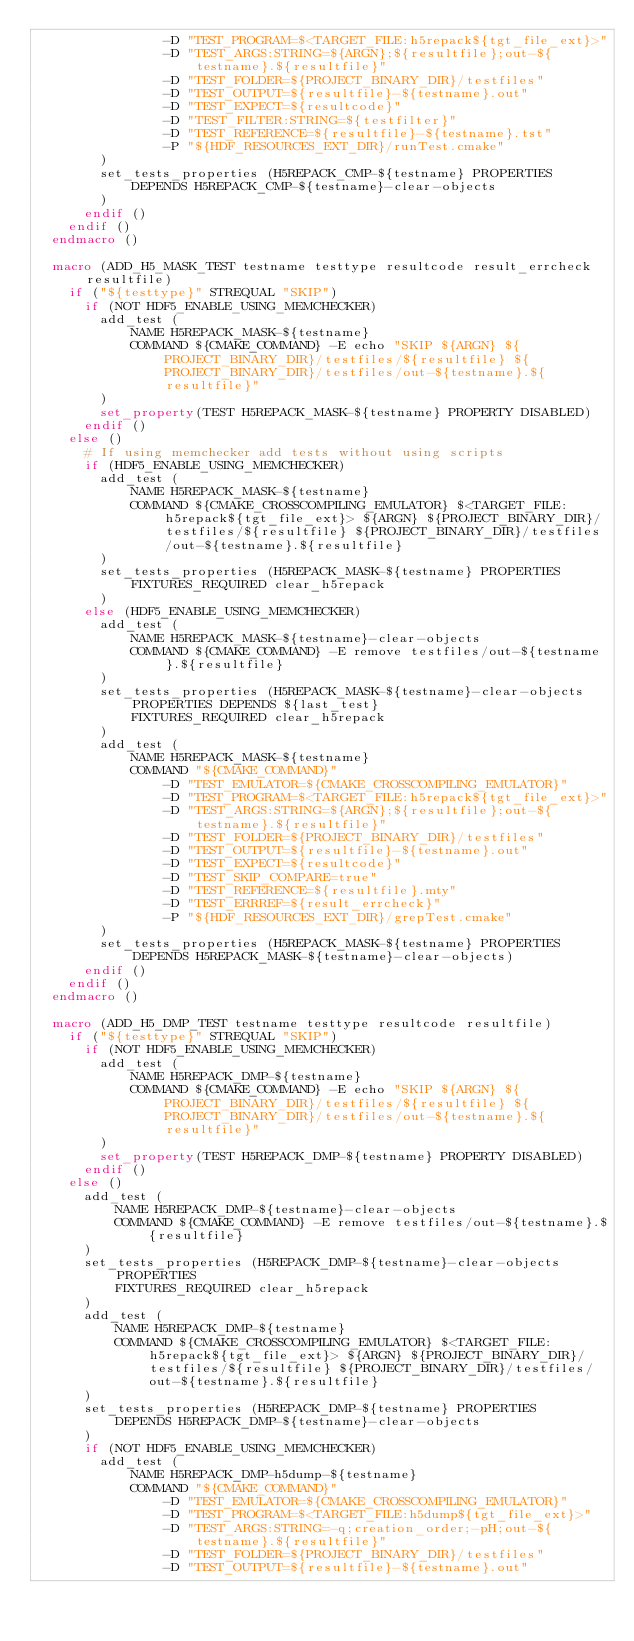<code> <loc_0><loc_0><loc_500><loc_500><_CMake_>                -D "TEST_PROGRAM=$<TARGET_FILE:h5repack${tgt_file_ext}>"
                -D "TEST_ARGS:STRING=${ARGN};${resultfile};out-${testname}.${resultfile}"
                -D "TEST_FOLDER=${PROJECT_BINARY_DIR}/testfiles"
                -D "TEST_OUTPUT=${resultfile}-${testname}.out"
                -D "TEST_EXPECT=${resultcode}"
                -D "TEST_FILTER:STRING=${testfilter}"
                -D "TEST_REFERENCE=${resultfile}-${testname}.tst"
                -P "${HDF_RESOURCES_EXT_DIR}/runTest.cmake"
        )
        set_tests_properties (H5REPACK_CMP-${testname} PROPERTIES
            DEPENDS H5REPACK_CMP-${testname}-clear-objects
        )
      endif ()
    endif ()
  endmacro ()

  macro (ADD_H5_MASK_TEST testname testtype resultcode result_errcheck resultfile)
    if ("${testtype}" STREQUAL "SKIP")
      if (NOT HDF5_ENABLE_USING_MEMCHECKER)
        add_test (
            NAME H5REPACK_MASK-${testname}
            COMMAND ${CMAKE_COMMAND} -E echo "SKIP ${ARGN} ${PROJECT_BINARY_DIR}/testfiles/${resultfile} ${PROJECT_BINARY_DIR}/testfiles/out-${testname}.${resultfile}"
        )
        set_property(TEST H5REPACK_MASK-${testname} PROPERTY DISABLED)
      endif ()
    else ()
      # If using memchecker add tests without using scripts
      if (HDF5_ENABLE_USING_MEMCHECKER)
        add_test (
            NAME H5REPACK_MASK-${testname}
            COMMAND ${CMAKE_CROSSCOMPILING_EMULATOR} $<TARGET_FILE:h5repack${tgt_file_ext}> ${ARGN} ${PROJECT_BINARY_DIR}/testfiles/${resultfile} ${PROJECT_BINARY_DIR}/testfiles/out-${testname}.${resultfile}
        )
        set_tests_properties (H5REPACK_MASK-${testname} PROPERTIES
            FIXTURES_REQUIRED clear_h5repack
        )
      else (HDF5_ENABLE_USING_MEMCHECKER)
        add_test (
            NAME H5REPACK_MASK-${testname}-clear-objects
            COMMAND ${CMAKE_COMMAND} -E remove testfiles/out-${testname}.${resultfile}
        )
        set_tests_properties (H5REPACK_MASK-${testname}-clear-objects PROPERTIES DEPENDS ${last_test}
            FIXTURES_REQUIRED clear_h5repack
        )
        add_test (
            NAME H5REPACK_MASK-${testname}
            COMMAND "${CMAKE_COMMAND}"
                -D "TEST_EMULATOR=${CMAKE_CROSSCOMPILING_EMULATOR}"
                -D "TEST_PROGRAM=$<TARGET_FILE:h5repack${tgt_file_ext}>"
                -D "TEST_ARGS:STRING=${ARGN};${resultfile};out-${testname}.${resultfile}"
                -D "TEST_FOLDER=${PROJECT_BINARY_DIR}/testfiles"
                -D "TEST_OUTPUT=${resultfile}-${testname}.out"
                -D "TEST_EXPECT=${resultcode}"
                -D "TEST_SKIP_COMPARE=true"
                -D "TEST_REFERENCE=${resultfile}.mty"
                -D "TEST_ERRREF=${result_errcheck}"
                -P "${HDF_RESOURCES_EXT_DIR}/grepTest.cmake"
        )
        set_tests_properties (H5REPACK_MASK-${testname} PROPERTIES DEPENDS H5REPACK_MASK-${testname}-clear-objects)
      endif ()
    endif ()
  endmacro ()

  macro (ADD_H5_DMP_TEST testname testtype resultcode resultfile)
    if ("${testtype}" STREQUAL "SKIP")
      if (NOT HDF5_ENABLE_USING_MEMCHECKER)
        add_test (
            NAME H5REPACK_DMP-${testname}
            COMMAND ${CMAKE_COMMAND} -E echo "SKIP ${ARGN} ${PROJECT_BINARY_DIR}/testfiles/${resultfile} ${PROJECT_BINARY_DIR}/testfiles/out-${testname}.${resultfile}"
        )
        set_property(TEST H5REPACK_DMP-${testname} PROPERTY DISABLED)
      endif ()
    else ()
      add_test (
          NAME H5REPACK_DMP-${testname}-clear-objects
          COMMAND ${CMAKE_COMMAND} -E remove testfiles/out-${testname}.${resultfile}
      )
      set_tests_properties (H5REPACK_DMP-${testname}-clear-objects PROPERTIES
          FIXTURES_REQUIRED clear_h5repack
      )
      add_test (
          NAME H5REPACK_DMP-${testname}
          COMMAND ${CMAKE_CROSSCOMPILING_EMULATOR} $<TARGET_FILE:h5repack${tgt_file_ext}> ${ARGN} ${PROJECT_BINARY_DIR}/testfiles/${resultfile} ${PROJECT_BINARY_DIR}/testfiles/out-${testname}.${resultfile}
      )
      set_tests_properties (H5REPACK_DMP-${testname} PROPERTIES
          DEPENDS H5REPACK_DMP-${testname}-clear-objects
      )
      if (NOT HDF5_ENABLE_USING_MEMCHECKER)
        add_test (
            NAME H5REPACK_DMP-h5dump-${testname}
            COMMAND "${CMAKE_COMMAND}"
                -D "TEST_EMULATOR=${CMAKE_CROSSCOMPILING_EMULATOR}"
                -D "TEST_PROGRAM=$<TARGET_FILE:h5dump${tgt_file_ext}>"
                -D "TEST_ARGS:STRING=-q;creation_order;-pH;out-${testname}.${resultfile}"
                -D "TEST_FOLDER=${PROJECT_BINARY_DIR}/testfiles"
                -D "TEST_OUTPUT=${resultfile}-${testname}.out"</code> 